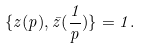<formula> <loc_0><loc_0><loc_500><loc_500>\{ z ( p ) , \bar { z } ( \frac { 1 } { p } ) \} = 1 .</formula> 